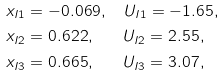<formula> <loc_0><loc_0><loc_500><loc_500>x _ { I 1 } & = - 0 . 0 6 9 , \quad U _ { I 1 } = - 1 . 6 5 , \\ x _ { I 2 } & = 0 . 6 2 2 , \quad \ \ U _ { I 2 } = 2 . 5 5 , \\ x _ { I 3 } & = 0 . 6 6 5 , \quad \ \ U _ { I 3 } = 3 . 0 7 ,</formula> 